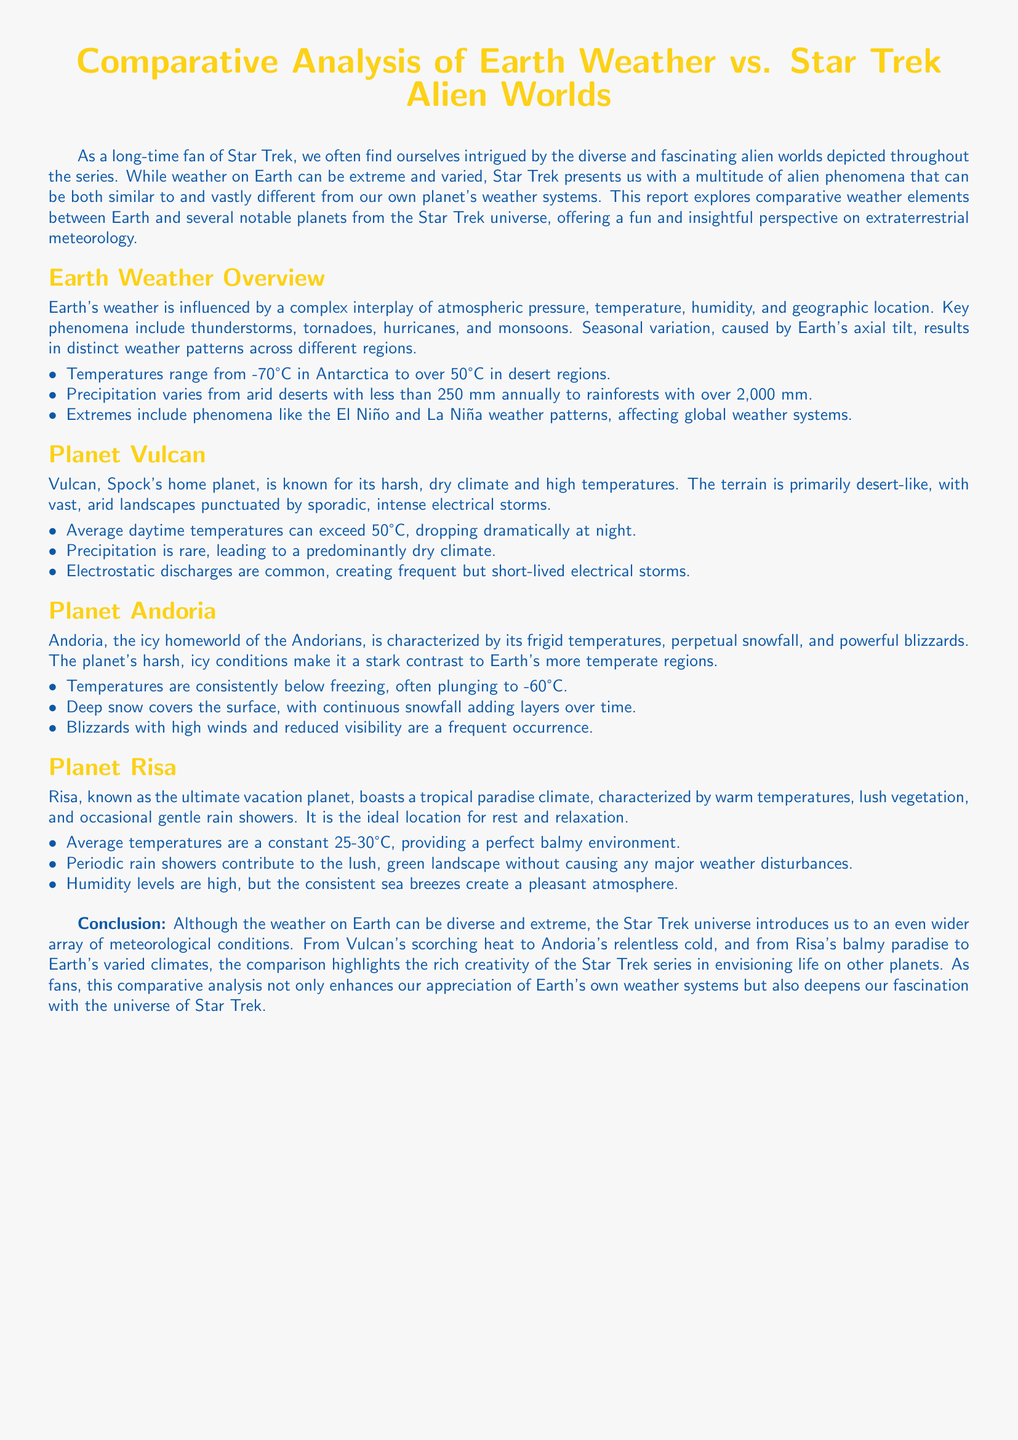What is the average temperature on Vulcan? The document states that average daytime temperatures on Vulcan can exceed 50°C.
Answer: Over 50°C What type of storms are common on Vulcan? The document mentions that electrostatic discharges are common, creating frequent but short-lived electrical storms.
Answer: Electrical storms What is the maximum temperature listed for Andoria? According to the document, temperatures on Andoria often plunge to -60°C.
Answer: -60°C How much precipitation does Earth receive in rainforests? The document indicates that rainforests can receive over 2,000 mm of precipitation annually.
Answer: Over 2,000 mm What is Risa known for? The document describes Risa as the ultimate vacation planet, characterized by a tropical paradise climate.
Answer: Ultimate vacation planet Which planet has deep snow and continuous snowfall? The document specifies that Andoria is characterized by deep snow and continuous snowfall.
Answer: Andoria What is the general climate description of Earth's weather? The document outlines that Earth’s weather is influenced by a complex interplay of atmospheric pressure, temperature, humidity, and geographic location.
Answer: Complex interplay What phenomenon affects global weather systems noted in the document? The document mentions El Niño and La Niña weather patterns as phenomena affecting global weather.
Answer: El Niño and La Niña What is the average temperature range on Risa? The document states that average temperatures on Risa are between 25-30°C.
Answer: 25-30°C 